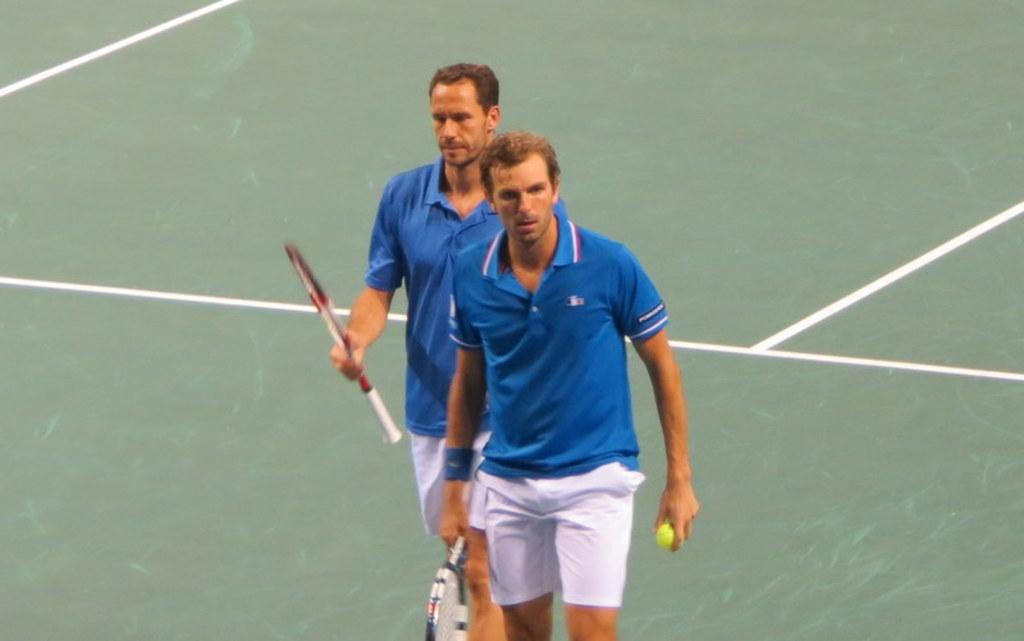How many sportsmen are in the image? There are two sportsmen in the image. What are the sportsmen doing in the image? The sportsmen are walking in a court. What objects are the sportsmen holding in their hands? The sportsmen are holding bats in their hands, and one of them is holding a tennis ball in his hand. What can be seen in the background of the image? There is a court visible in the background of the image. What type of cave can be seen in the image? There is no cave present in the image; it features two sportsmen walking in a court. What advice does the mom give to the sportsmen in the image? There is no mom present in the image, and therefore no advice can be given. 